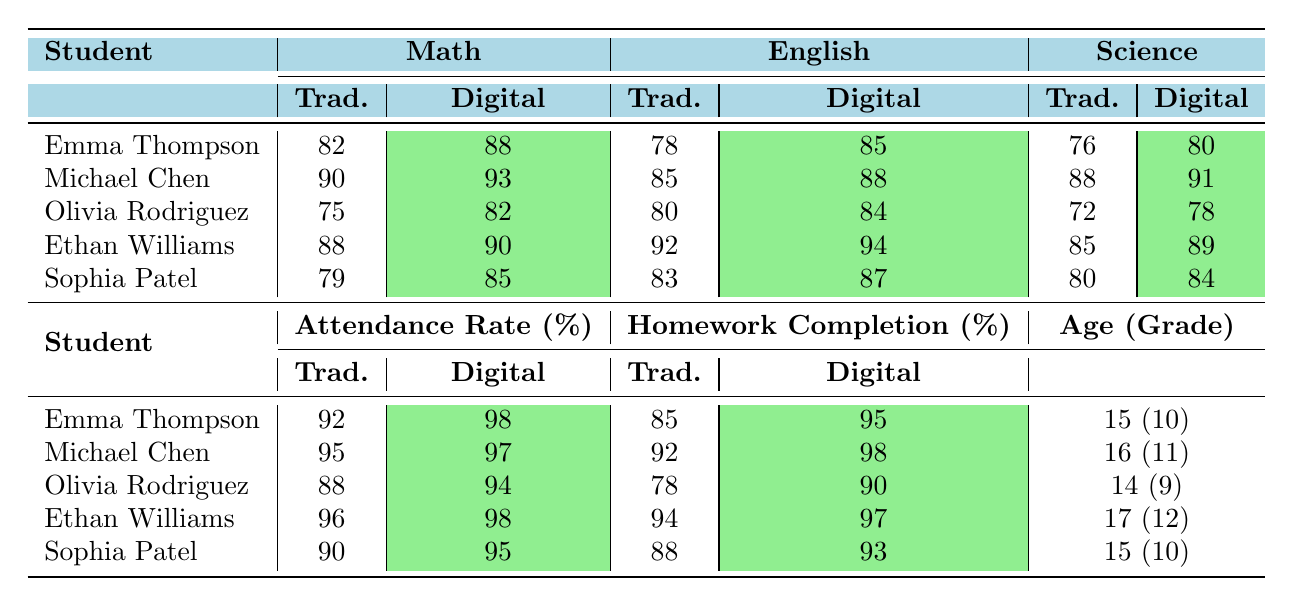What is Emma Thompson's digital math score? The table shows that Emma Thompson's digital math score is listed directly under the Digital column for Math, which indicates a score of 88.
Answer: 88 Which student has the highest traditional English score? By reviewing the Traditional English scores in the table, Michael Chen has the highest score, which is 85.
Answer: Michael Chen What is the difference between Ethan Williams' traditional and digital science scores? To find the difference, subtract Ethan Williams' traditional science score (85) from his digital science score (89). The calculation is 89 - 85 = 4.
Answer: 4 What percentage of homework completion did Olivia Rodriguez achieve in digital learning? The table specifies that Olivia Rodriguez's digital homework completion rate is 90%, as listed under the Digital column for Homework Completion.
Answer: 90% Is the digital attendance rate for any student less than 95%? A quick check of the Digital attendance rates shows that the lowest value is 94% for Olivia Rodriguez, hence it is true that at least one student has a digital attendance rate less than 95%.
Answer: Yes What is the average traditional math score of all students? To calculate the average, add the traditional math scores: 82 + 90 + 75 + 88 + 79 = 414. Then divide by the number of students (5): 414 / 5 = 82.8.
Answer: 82.8 Which learning method has a higher average attendance rate, traditional or digital? The traditional attendance rates are 92, 95, 88, 96, and 90, averaging to (92 + 95 + 88 + 96 + 90) / 5 = 92.2. The digital rates are 98, 97, 94, 98, and 95, averaging to (98 + 97 + 94 + 98 + 95) / 5 = 96.4. Comparing these averages, the digital attendance rate is higher.
Answer: Digital How many students had a digital English score of 90 or above? Looking at the Digital English scores, calculating the number of scores that are 90 or above shows that Michael Chen (88), Ethan Williams (94), and Sophia Patel (87) meet this criterion, giving a total of 3 students.
Answer: 3 What is the overall trend for the scores in digital learning compared to traditional learning for Michael Chen? Reviewing Michael Chen's scores, he scored higher in digital for Math (93 vs. 90), English (88 vs. 85), and Science (91 vs. 88). Hence, all his digital scores are higher than his traditional scores.
Answer: Higher in all subjects Which student had the lowest overall traditional score across all subjects? First, calculate the total traditional scores: Emma (82 + 78 + 76 = 236), Michael (90 + 85 + 88 = 263), Olivia (75 + 80 + 72 = 227), Ethan (88 + 92 + 85 = 265), Sophia (79 + 83 + 80 = 242). The lowest score is Olivia Rodriguez with 227 points.
Answer: Olivia Rodriguez 